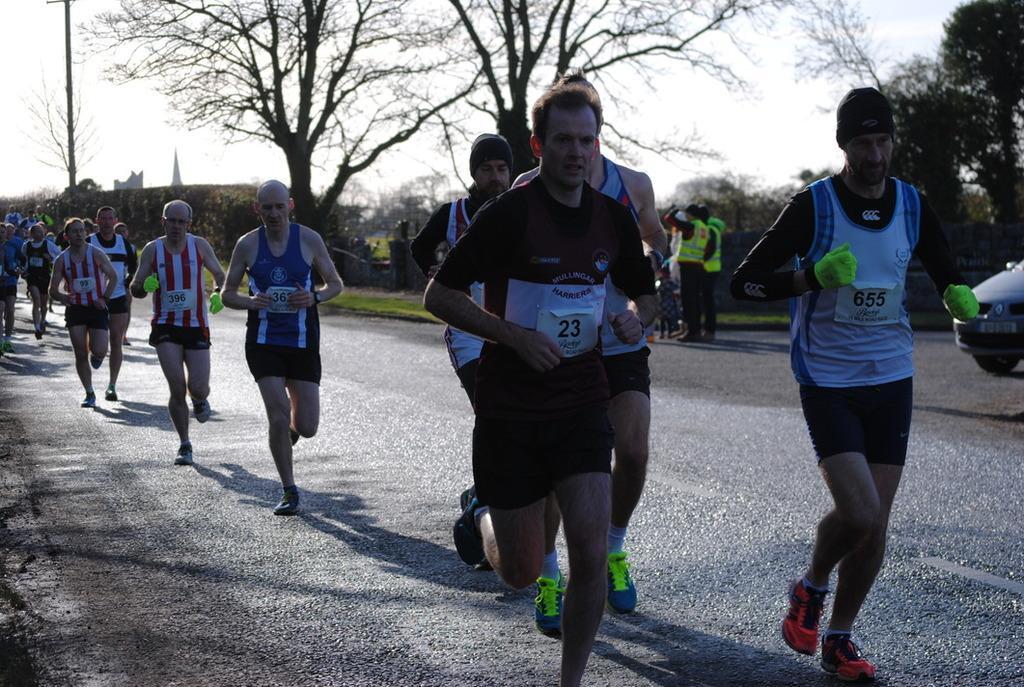Could you give a brief overview of what you see in this image? In this picture there are group of people running on the road. At the back there is a vehicle and there are group of people standing and there is a building and pole and there are trees. At the top there is sky. At the bottom there is a road and there is grass. 